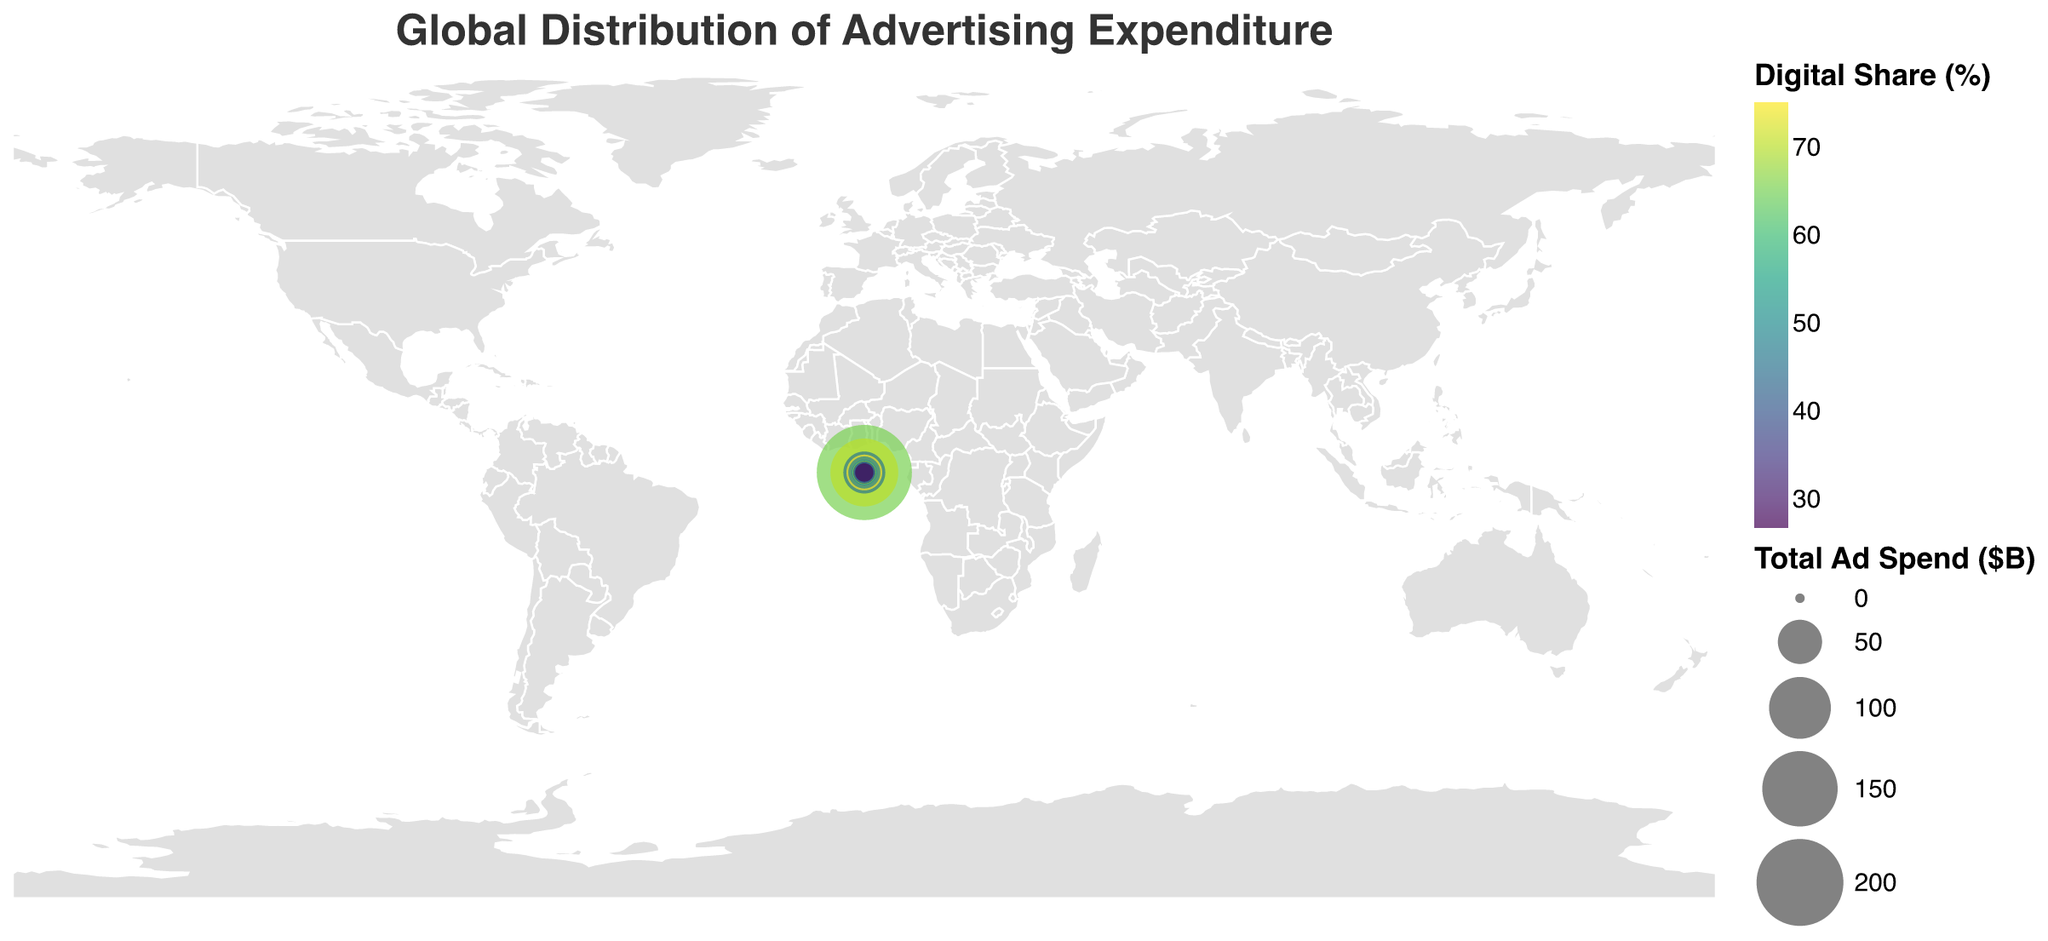What is the title of the figure? The title is displayed at the top of the figure in a large, readable font and serves as a summary of the data.
Answer: Global Distribution of Advertising Expenditure Which country has the highest total advertising spend? Look at the size of the circles on the map; the largest circle represents the highest total ad spend. The United States has the largest circle.
Answer: United States What color represents the highest digital share on the map? The color legend indicates that a lighter color represents a higher digital share.
Answer: Yellowish-green Which country has the lowest share of digital advertising? Identify the country with the largest traditional share (complementary to digital share). Indonesia has the largest traditional share.
Answer: Indonesia How does digital share in the United States compare to that in China? Look at the color of circles for both countries. The legend shows that the United States is dark-green (65.3%) and China is lighter green (70.2%).
Answer: China's digital share is higher What is the combined total advertising spend of Japan, Germany, and Brazil? Add the TotalAdSpend values for Japan (44.8), Germany (25.3), and Brazil (14.2). The result is 44.8 + 25.3 + 14.2 = 84.3.
Answer: 84.3 billion USD Which countries spend more on traditional media compared to digital? Look for countries with higher traditional share than digital share using circle colors and position on the map. Brazil, India, Italy, Spain, and Indonesia fit this criterion.
Answer: Brazil, India, Italy, Spain, Indonesia What is the average digital share across all the countries? Calculate the sum of all the digital shares and divide by the number of countries (15). The total digital share sum is 841.8. 841.8/15 = 56.12.
Answer: 56.12% Which country in the Americas has the smallest total advertising spend? Focus on countries in the Americas and look at the smallest circle among them. Canada has the smallest circle.
Answer: Canada 